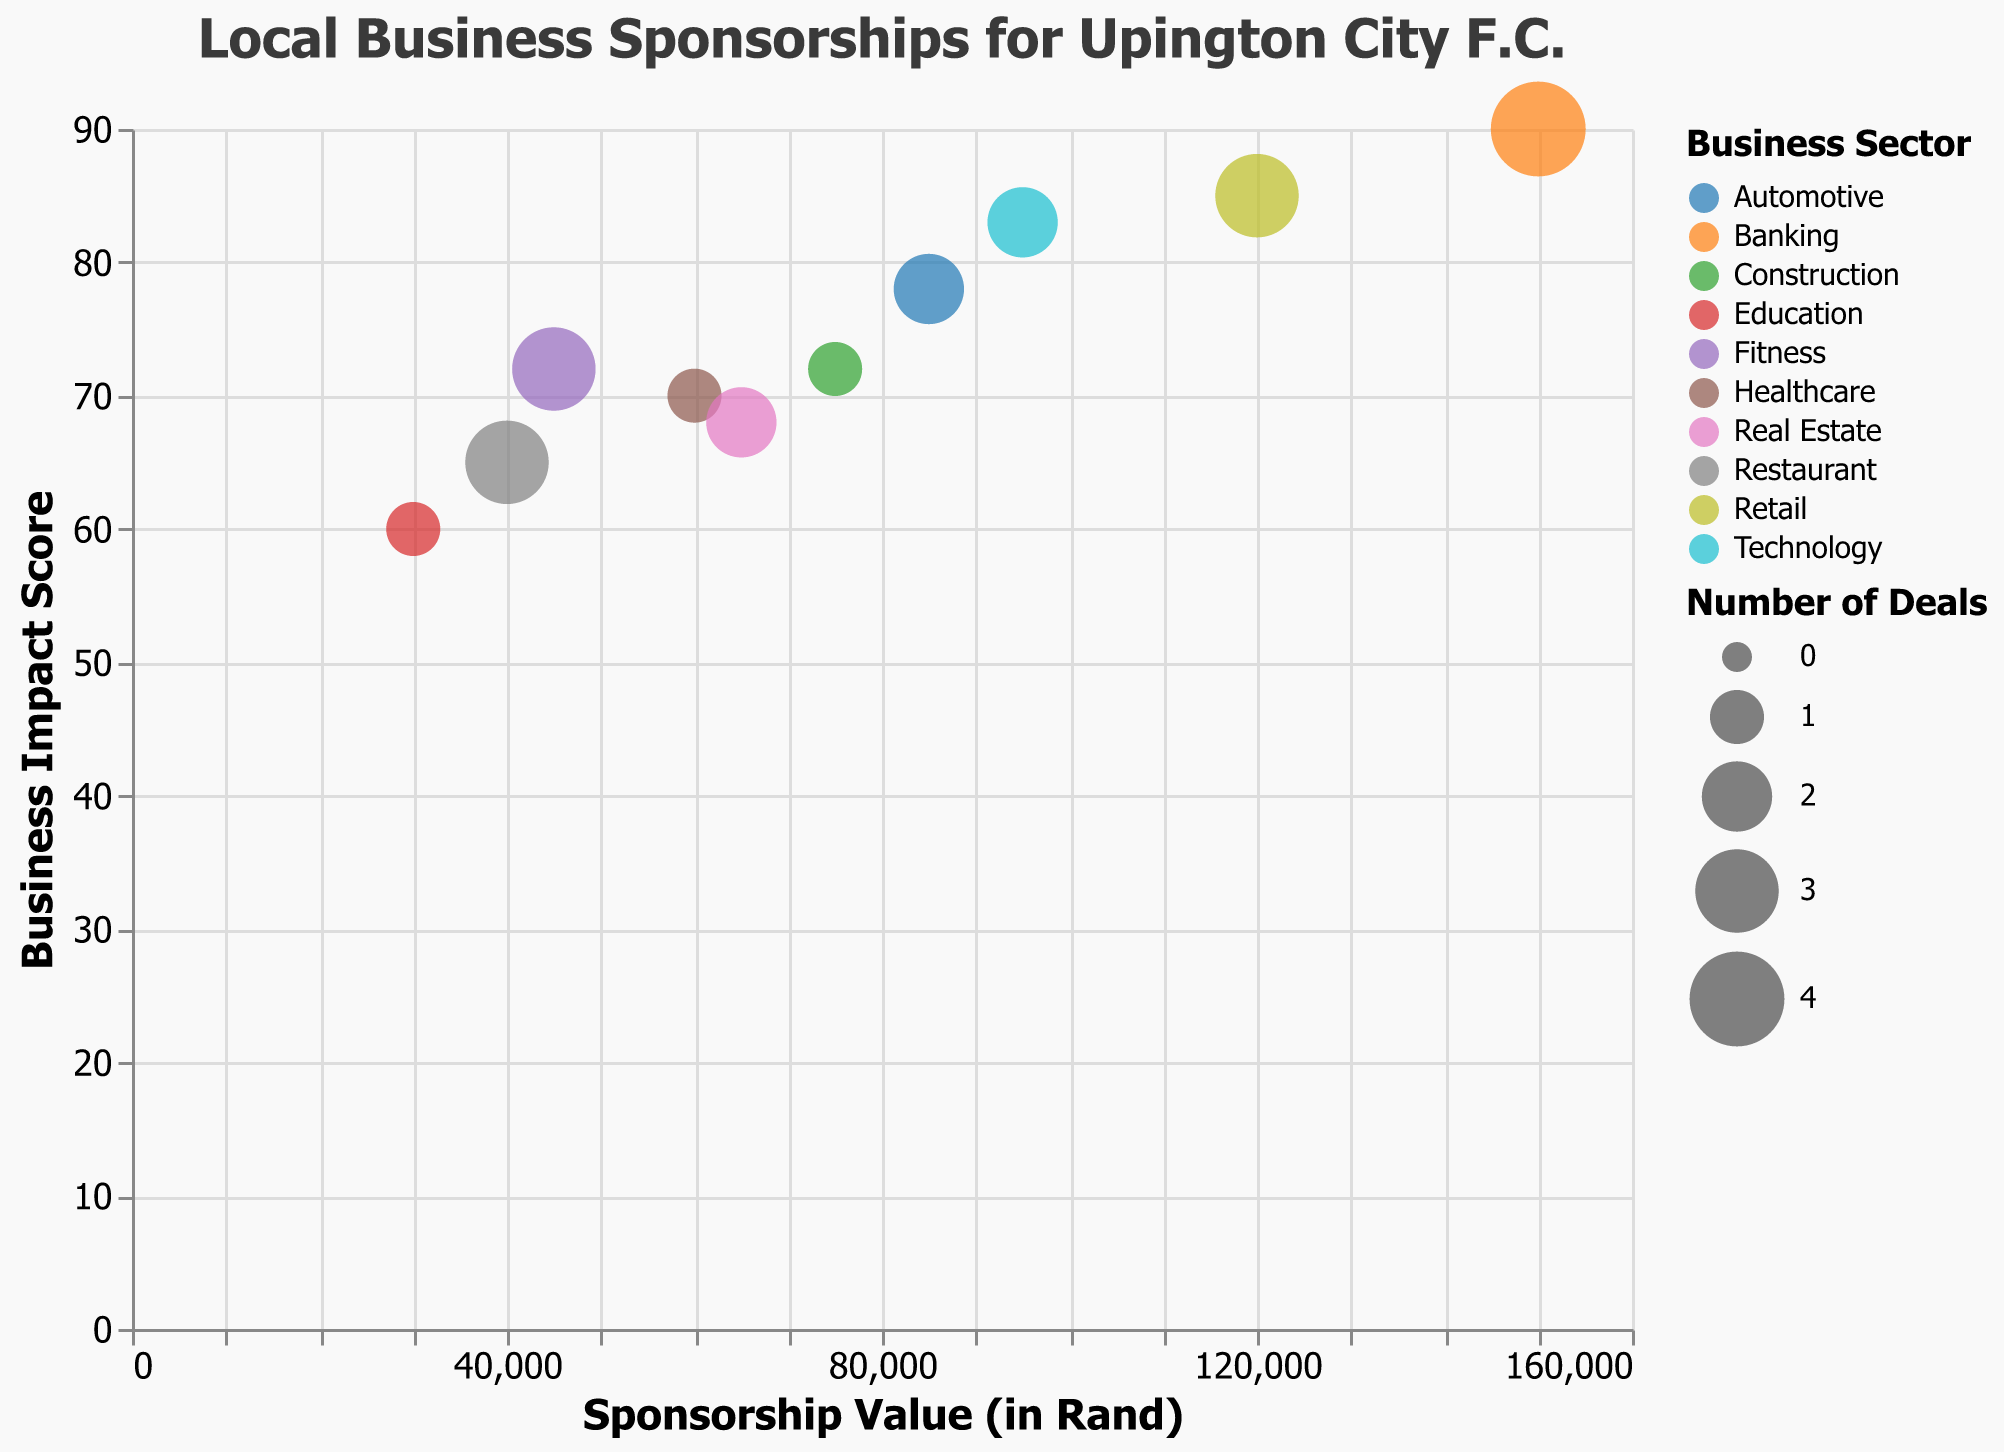What is the title of the bubble chart? The title is usually found at the top of the chart, clearly indicating what the data represents. Here, the title is "Local Business Sponsorships for Upington City F.C."
Answer: Local Business Sponsorships for Upington City F.C Which business sector has the highest sponsorship value? By looking at the x-axis, which represents the sponsorship value, the furthest point to the right indicates the highest value. Banking has the highest sponsorship value at 150,000 Rand
Answer: Banking How many business sectors have only 1 deal? Each bubble size represents the number of deals. Smaller bubbles indicate fewer deals. By visually inspecting the bubble sizes and checking the tooltip, the sectors with only 1 deal are Healthcare, Construction, and Education.
Answer: 3 What is the business impact score for the Retail sector? Locate the Retail sector bubble and refer to its position on the y-axis, which represents the business impact score. Retail's bubble is placed at an impact score of 85.
Answer: 85 Which business sector has the smallest sponsorship value and how much is it? Look for the bubble located furthest to the left on the x-axis. The smallest value is for the Education sector, with a sponsorship value of 30,000 Rand.
Answer: Education, 30,000 Rand Order the business sectors by number of deals, starting from the most. Identify the bubble sizes, as they represent the number of deals. The largest bubbles indicate the highest number. Banking has 4 deals, while Retail, Restaurant, and Fitness each have 3 deals, Automotive and Technology have 2, and Healthcare, Construction, Real Estate, and Education each have 1 deal.
Answer: Banking > Retail = Restaurant = Fitness > Automotive = Technology > Healthcare = Construction = Real Estate = Education What is the average sponsorship value for sectors with more than 2 deals? Identify the bubbles with more than 2 deals using their size (Retail, Banking, Restaurant, Fitness). Sum their sponsorship values: 120,000 (Retail) + 150,000 (Banking) + 40,000 (Restaurant) + 45,000 (Fitness) = 355,000. Divide by the number of sectors (4) to get the average.
Answer: 88,750 Rand Comparing Automotive and Technology sectors, which has a higher business impact score? Locate both sectors and check their positions on the y-axis. Technology's bubble is higher than Automotive's on the y-axis, indicating a higher business impact score.
Answer: Technology Which business sectors have a business impact score less than 70? Look for bubbles located below the 70 mark on the y-axis. The sectors are Restaurant (65), Real Estate (68), and Education (60).
Answer: Restaurant, Real Estate, Education Are there any sectors with the same sponsorship value but different number of deals? If so, which ones? Compare the bubbles' x-axis positions and sizes. Real Estate and Construction have the same sponsorship value of 65,000 Rand, but Real Estate has 2 deals, while Construction has 1 deal.
Answer: Real Estate, Construction 